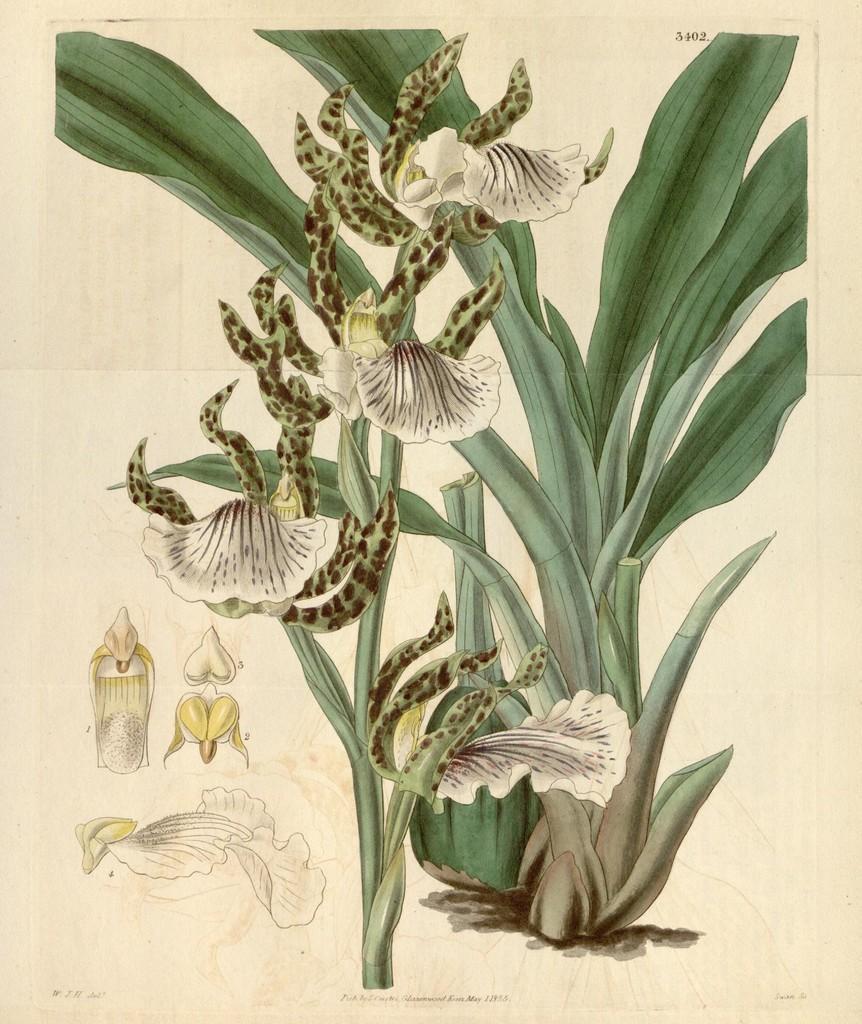Describe this image in one or two sentences. This picture looks like a painting in which i can see a plant with some flowers. 